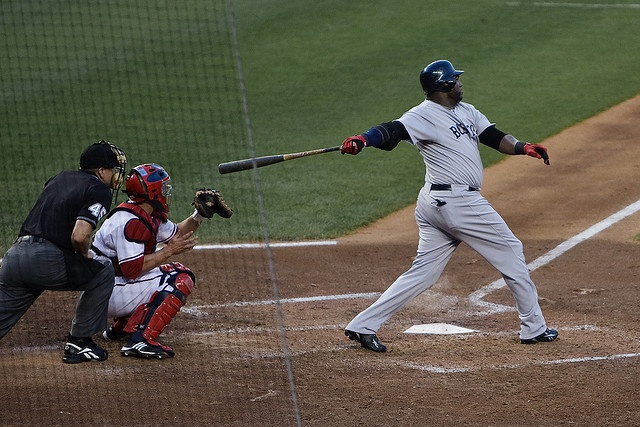Describe the objects in this image and their specific colors. I can see people in black, darkgray, and gray tones, people in black, gray, and darkgreen tones, people in black, maroon, gray, and darkgray tones, baseball bat in black, gray, darkgreen, and darkgray tones, and baseball glove in black and gray tones in this image. 